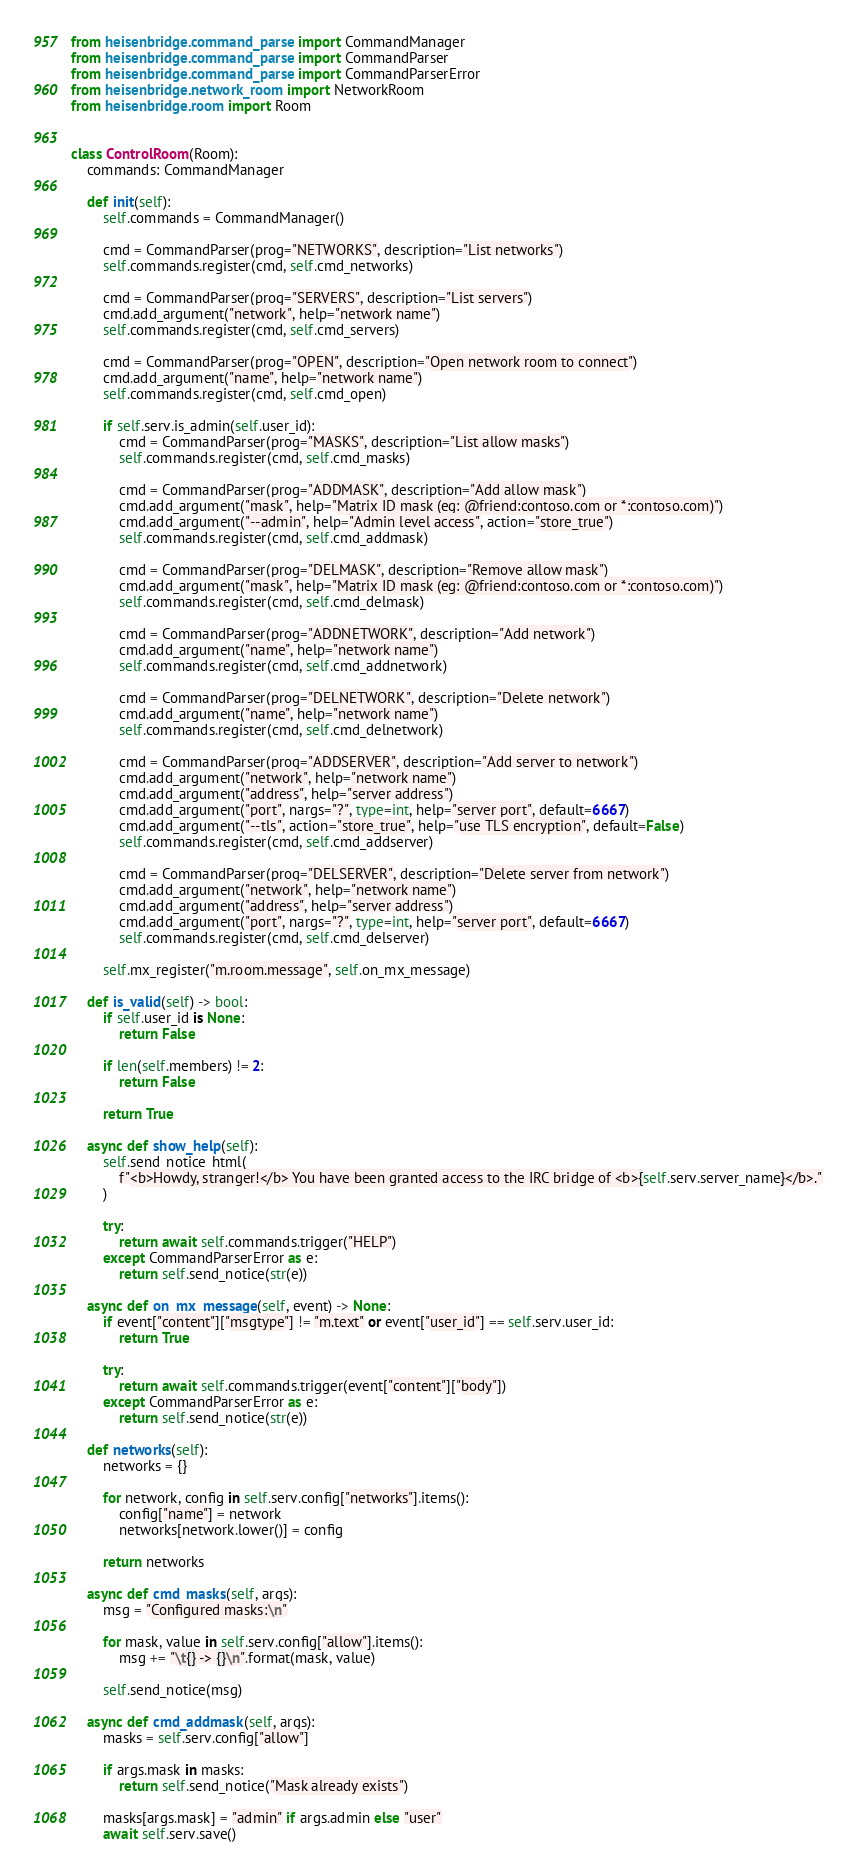<code> <loc_0><loc_0><loc_500><loc_500><_Python_>from heisenbridge.command_parse import CommandManager
from heisenbridge.command_parse import CommandParser
from heisenbridge.command_parse import CommandParserError
from heisenbridge.network_room import NetworkRoom
from heisenbridge.room import Room


class ControlRoom(Room):
    commands: CommandManager

    def init(self):
        self.commands = CommandManager()

        cmd = CommandParser(prog="NETWORKS", description="List networks")
        self.commands.register(cmd, self.cmd_networks)

        cmd = CommandParser(prog="SERVERS", description="List servers")
        cmd.add_argument("network", help="network name")
        self.commands.register(cmd, self.cmd_servers)

        cmd = CommandParser(prog="OPEN", description="Open network room to connect")
        cmd.add_argument("name", help="network name")
        self.commands.register(cmd, self.cmd_open)

        if self.serv.is_admin(self.user_id):
            cmd = CommandParser(prog="MASKS", description="List allow masks")
            self.commands.register(cmd, self.cmd_masks)

            cmd = CommandParser(prog="ADDMASK", description="Add allow mask")
            cmd.add_argument("mask", help="Matrix ID mask (eg: @friend:contoso.com or *:contoso.com)")
            cmd.add_argument("--admin", help="Admin level access", action="store_true")
            self.commands.register(cmd, self.cmd_addmask)

            cmd = CommandParser(prog="DELMASK", description="Remove allow mask")
            cmd.add_argument("mask", help="Matrix ID mask (eg: @friend:contoso.com or *:contoso.com)")
            self.commands.register(cmd, self.cmd_delmask)

            cmd = CommandParser(prog="ADDNETWORK", description="Add network")
            cmd.add_argument("name", help="network name")
            self.commands.register(cmd, self.cmd_addnetwork)

            cmd = CommandParser(prog="DELNETWORK", description="Delete network")
            cmd.add_argument("name", help="network name")
            self.commands.register(cmd, self.cmd_delnetwork)

            cmd = CommandParser(prog="ADDSERVER", description="Add server to network")
            cmd.add_argument("network", help="network name")
            cmd.add_argument("address", help="server address")
            cmd.add_argument("port", nargs="?", type=int, help="server port", default=6667)
            cmd.add_argument("--tls", action="store_true", help="use TLS encryption", default=False)
            self.commands.register(cmd, self.cmd_addserver)

            cmd = CommandParser(prog="DELSERVER", description="Delete server from network")
            cmd.add_argument("network", help="network name")
            cmd.add_argument("address", help="server address")
            cmd.add_argument("port", nargs="?", type=int, help="server port", default=6667)
            self.commands.register(cmd, self.cmd_delserver)

        self.mx_register("m.room.message", self.on_mx_message)

    def is_valid(self) -> bool:
        if self.user_id is None:
            return False

        if len(self.members) != 2:
            return False

        return True

    async def show_help(self):
        self.send_notice_html(
            f"<b>Howdy, stranger!</b> You have been granted access to the IRC bridge of <b>{self.serv.server_name}</b>."
        )

        try:
            return await self.commands.trigger("HELP")
        except CommandParserError as e:
            return self.send_notice(str(e))

    async def on_mx_message(self, event) -> None:
        if event["content"]["msgtype"] != "m.text" or event["user_id"] == self.serv.user_id:
            return True

        try:
            return await self.commands.trigger(event["content"]["body"])
        except CommandParserError as e:
            return self.send_notice(str(e))

    def networks(self):
        networks = {}

        for network, config in self.serv.config["networks"].items():
            config["name"] = network
            networks[network.lower()] = config

        return networks

    async def cmd_masks(self, args):
        msg = "Configured masks:\n"

        for mask, value in self.serv.config["allow"].items():
            msg += "\t{} -> {}\n".format(mask, value)

        self.send_notice(msg)

    async def cmd_addmask(self, args):
        masks = self.serv.config["allow"]

        if args.mask in masks:
            return self.send_notice("Mask already exists")

        masks[args.mask] = "admin" if args.admin else "user"
        await self.serv.save()
</code> 